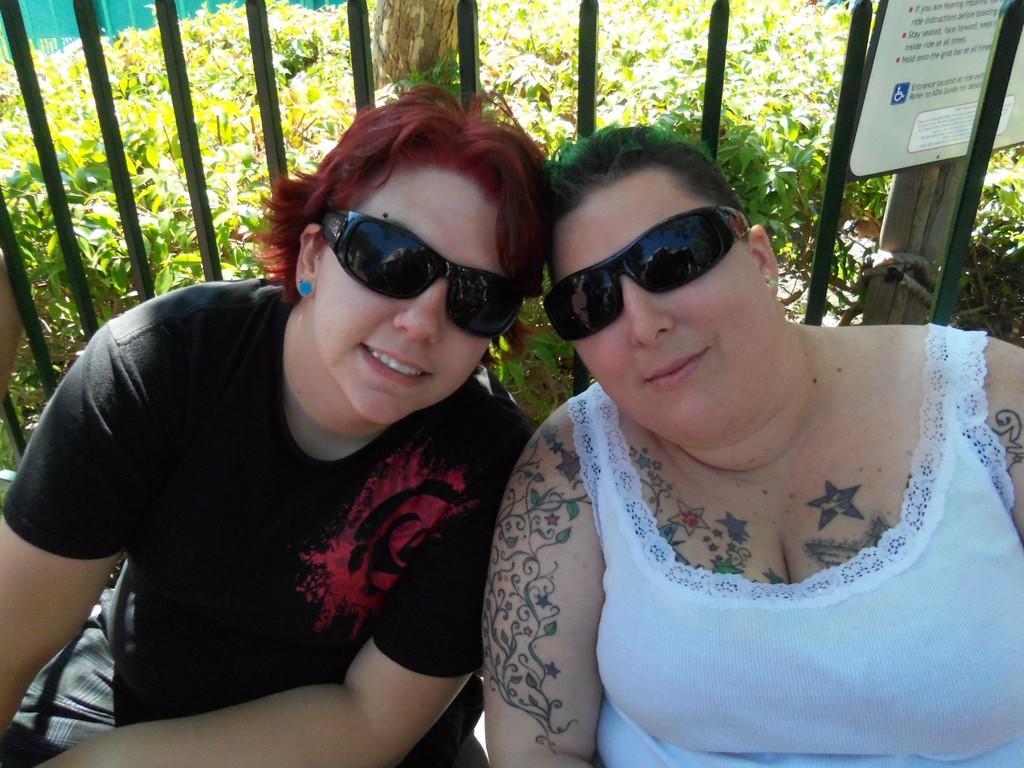Can you describe this image briefly? In this image we can see two women sitting wearing the glasses. On the backside we can see some metal poles, a board with some text on it, a wooden pole, some plants and a fence. 